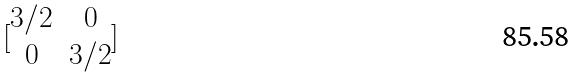Convert formula to latex. <formula><loc_0><loc_0><loc_500><loc_500>[ \begin{matrix} 3 / 2 & 0 \\ 0 & 3 / 2 \end{matrix} ]</formula> 